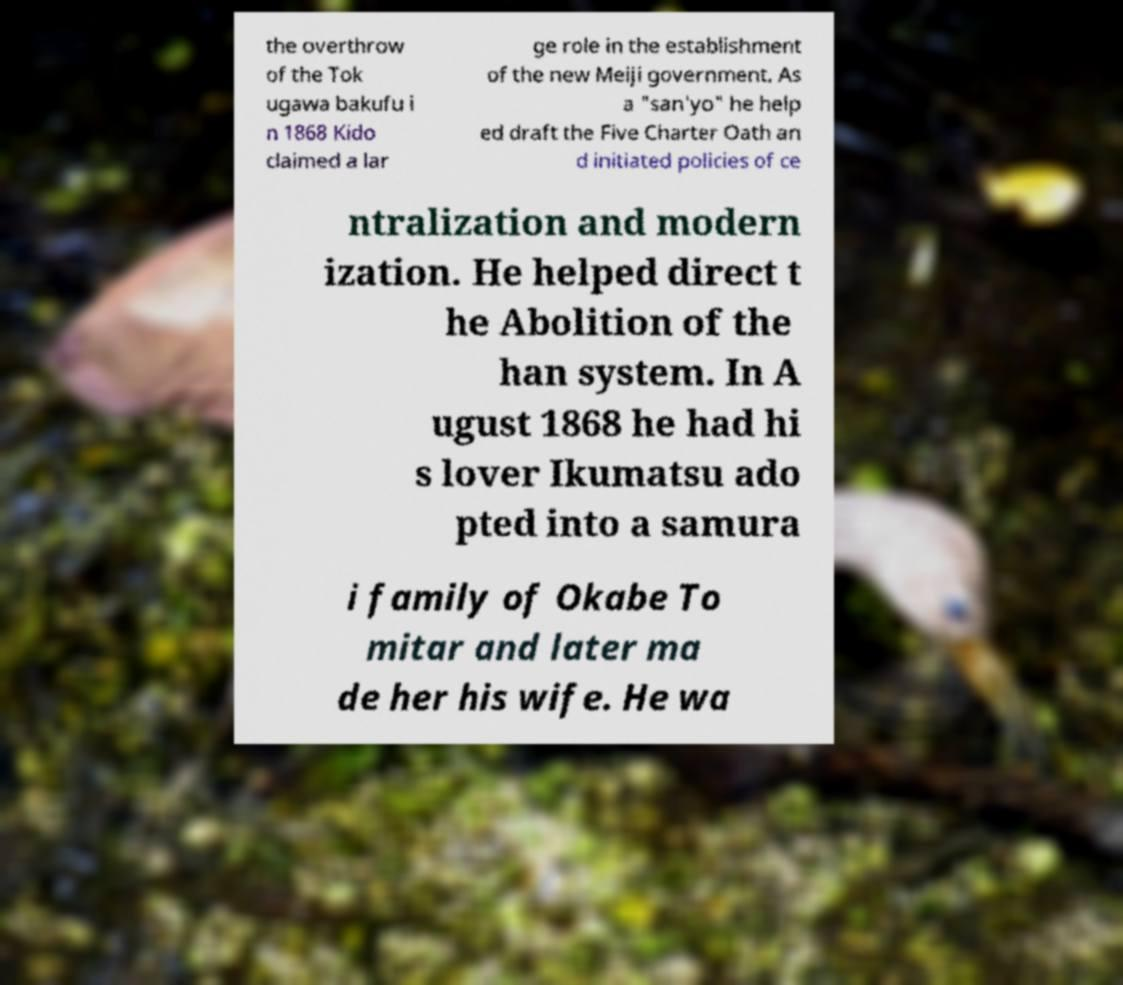Please identify and transcribe the text found in this image. the overthrow of the Tok ugawa bakufu i n 1868 Kido claimed a lar ge role in the establishment of the new Meiji government. As a "san'yo" he help ed draft the Five Charter Oath an d initiated policies of ce ntralization and modern ization. He helped direct t he Abolition of the han system. In A ugust 1868 he had hi s lover Ikumatsu ado pted into a samura i family of Okabe To mitar and later ma de her his wife. He wa 